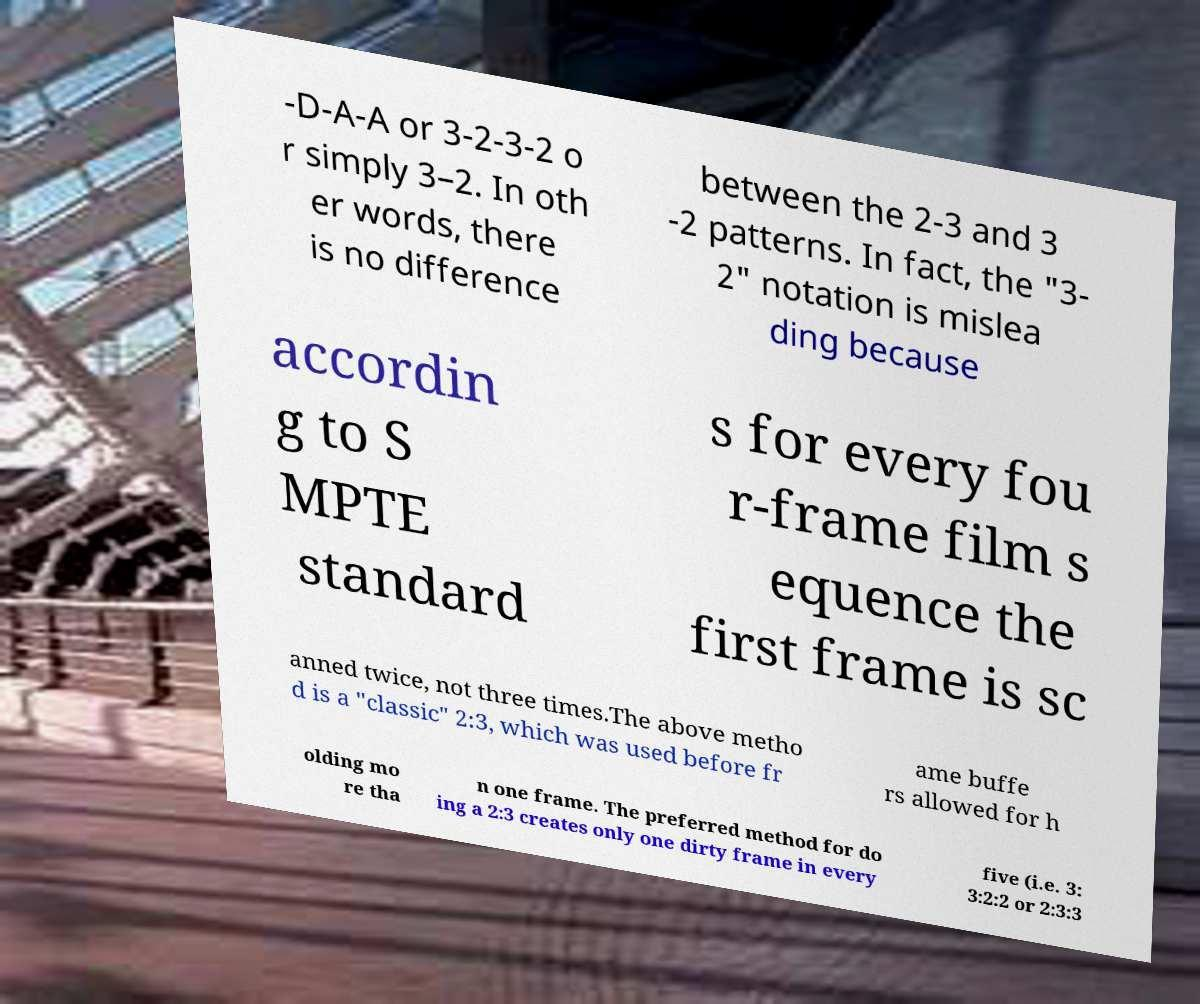Could you assist in decoding the text presented in this image and type it out clearly? -D-A-A or 3-2-3-2 o r simply 3–2. In oth er words, there is no difference between the 2-3 and 3 -2 patterns. In fact, the "3- 2" notation is mislea ding because accordin g to S MPTE standard s for every fou r-frame film s equence the first frame is sc anned twice, not three times.The above metho d is a "classic" 2:3, which was used before fr ame buffe rs allowed for h olding mo re tha n one frame. The preferred method for do ing a 2:3 creates only one dirty frame in every five (i.e. 3: 3:2:2 or 2:3:3 